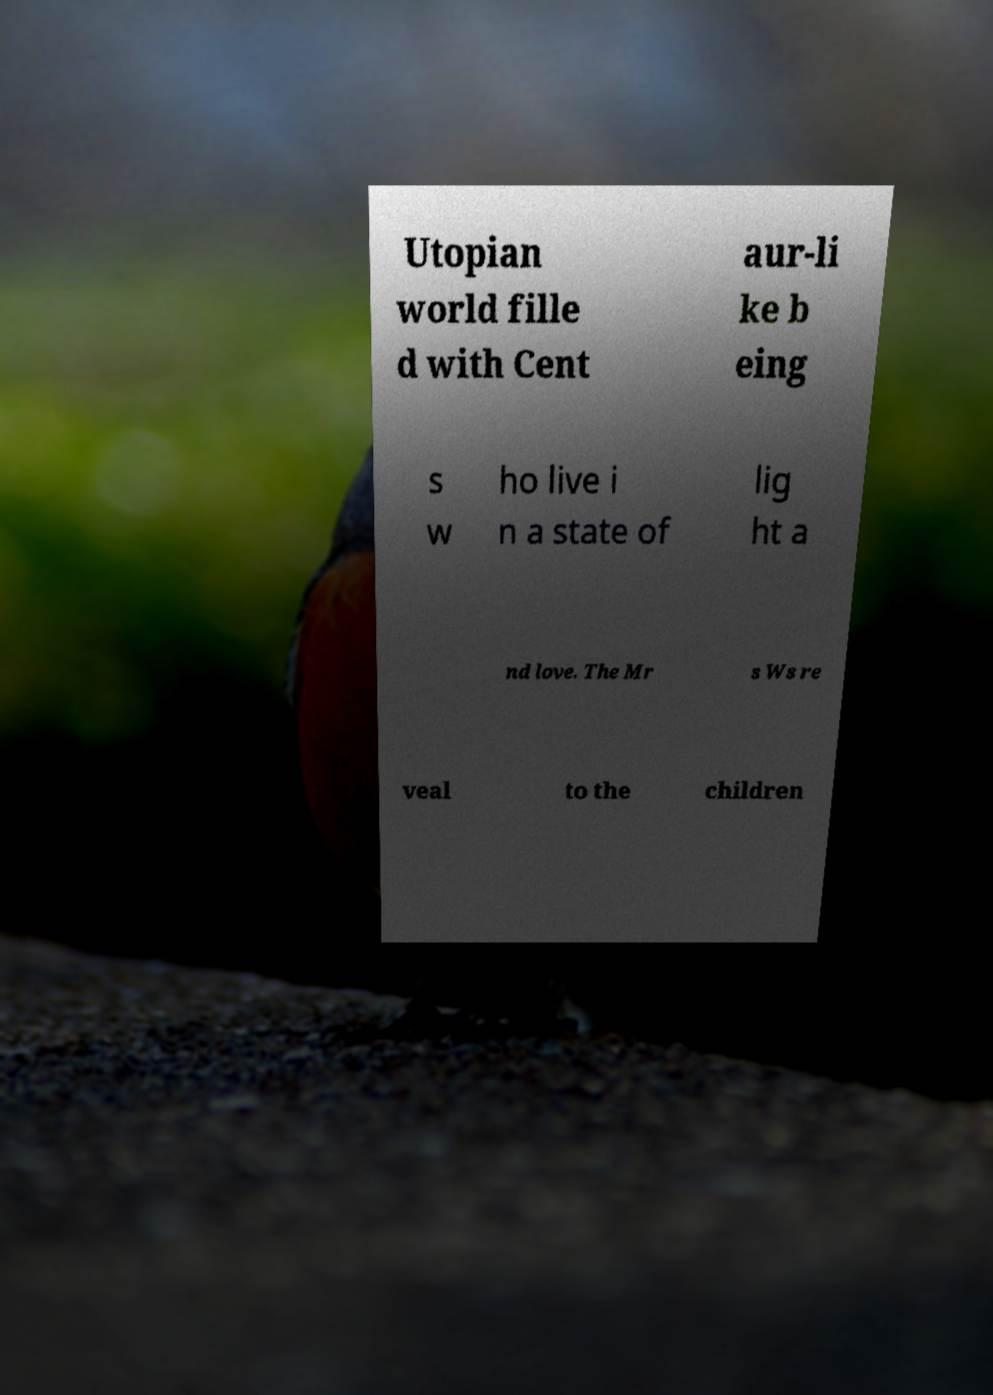Please identify and transcribe the text found in this image. Utopian world fille d with Cent aur-li ke b eing s w ho live i n a state of lig ht a nd love. The Mr s Ws re veal to the children 